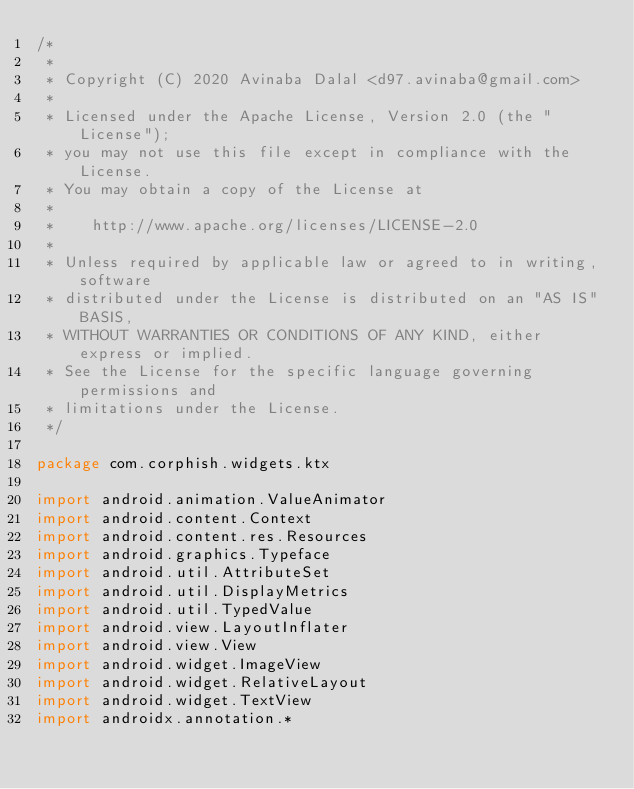<code> <loc_0><loc_0><loc_500><loc_500><_Kotlin_>/*
 *
 * Copyright (C) 2020 Avinaba Dalal <d97.avinaba@gmail.com>
 *
 * Licensed under the Apache License, Version 2.0 (the "License");
 * you may not use this file except in compliance with the License.
 * You may obtain a copy of the License at
 *
 *    http://www.apache.org/licenses/LICENSE-2.0
 *
 * Unless required by applicable law or agreed to in writing, software
 * distributed under the License is distributed on an "AS IS" BASIS,
 * WITHOUT WARRANTIES OR CONDITIONS OF ANY KIND, either express or implied.
 * See the License for the specific language governing permissions and
 * limitations under the License.
 */

package com.corphish.widgets.ktx

import android.animation.ValueAnimator
import android.content.Context
import android.content.res.Resources
import android.graphics.Typeface
import android.util.AttributeSet
import android.util.DisplayMetrics
import android.util.TypedValue
import android.view.LayoutInflater
import android.view.View
import android.widget.ImageView
import android.widget.RelativeLayout
import android.widget.TextView
import androidx.annotation.*</code> 